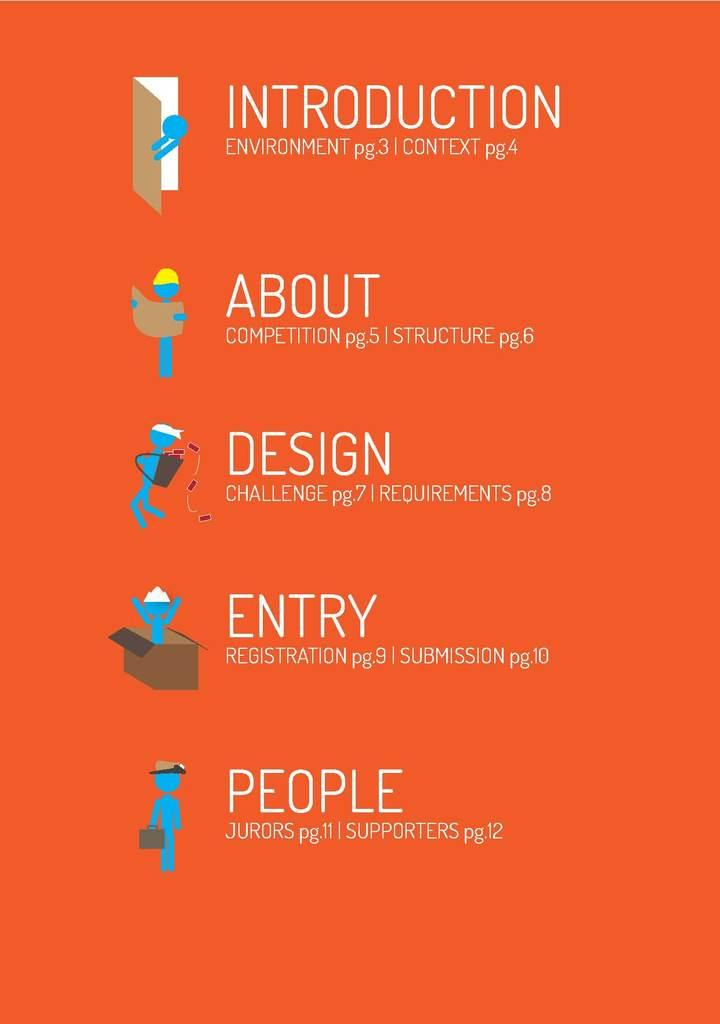<image>
Offer a succinct explanation of the picture presented. An index to a book which contains an introduction, about, design, entry and people. 